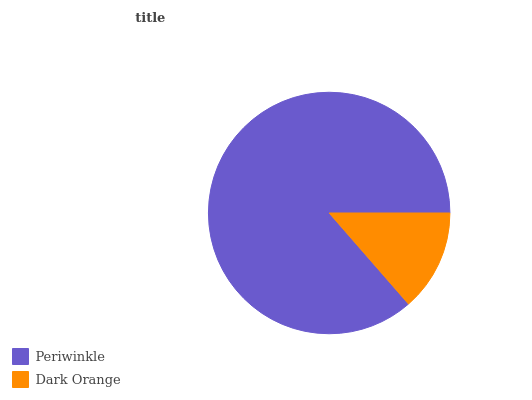Is Dark Orange the minimum?
Answer yes or no. Yes. Is Periwinkle the maximum?
Answer yes or no. Yes. Is Dark Orange the maximum?
Answer yes or no. No. Is Periwinkle greater than Dark Orange?
Answer yes or no. Yes. Is Dark Orange less than Periwinkle?
Answer yes or no. Yes. Is Dark Orange greater than Periwinkle?
Answer yes or no. No. Is Periwinkle less than Dark Orange?
Answer yes or no. No. Is Periwinkle the high median?
Answer yes or no. Yes. Is Dark Orange the low median?
Answer yes or no. Yes. Is Dark Orange the high median?
Answer yes or no. No. Is Periwinkle the low median?
Answer yes or no. No. 